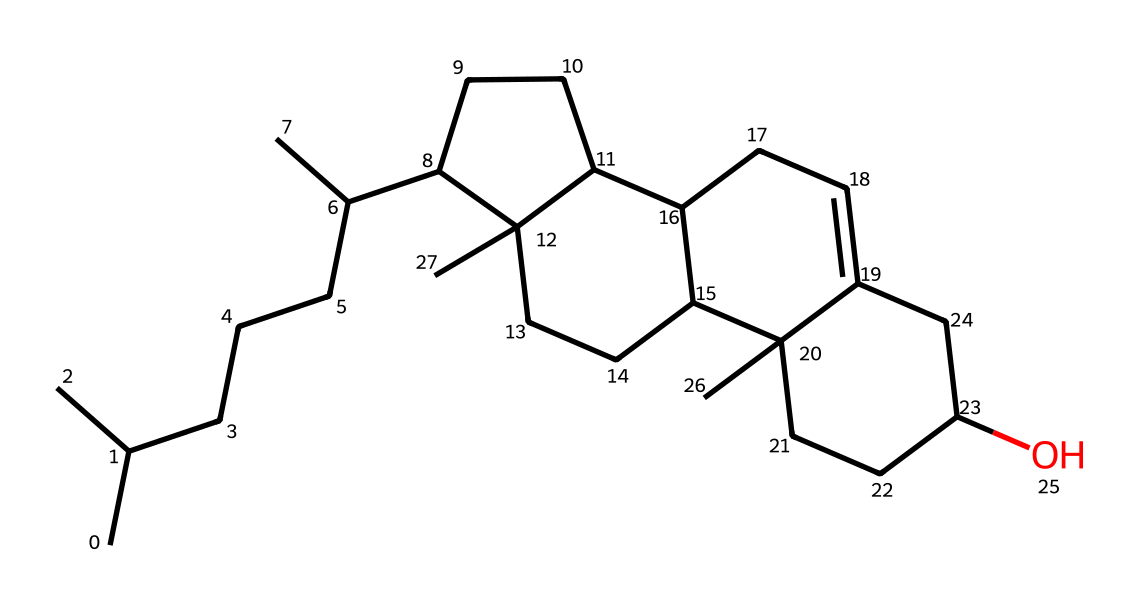What is the molecular formula of the cholesterol represented by this SMILES? The SMILES notation can be interpreted to identify the number of carbon (C), hydrogen (H), and oxygen (O) atoms. Counting from the structure yields 27 carbon atoms, 46 hydrogen atoms, and 1 oxygen atom, leading to the formula C27H46O.
Answer: C27H46O How many rings are present in the cholesterol structure? By analyzing the structure, we can identify parts of the molecule that form closed loops or rings. In this structure, there are four interconnected rings present in cholesterol.
Answer: four What is the primary role of cholesterol in cell membranes? Understanding the function of cholesterol in biological systems indicates its role in maintaining membrane fluidity and stability by modulating the arrangement of phospholipids in the cell membrane.
Answer: membrane fluidity What type of lipid does this structure represent? Observing the specific arrangement and function of the molecule, it becomes clear that this structure is categorized as a sterol, which is a subgroup of steroids.
Answer: sterol How many double bonds are present in this cholesterol structure? By examining the SMILES representation, we can note which parts of the structure contain double bonds. In this case, there is one double bond present, typically found within the cycloalkane rings.
Answer: one What characteristic feature distinguishes cholesterol from other lipids? A distinguishing feature of cholesterol that sets it apart from other lipids is the presence of a hydroxyl group (-OH), indicating its role as a sterol and affecting its solubility and function within membranes.
Answer: hydroxyl group 